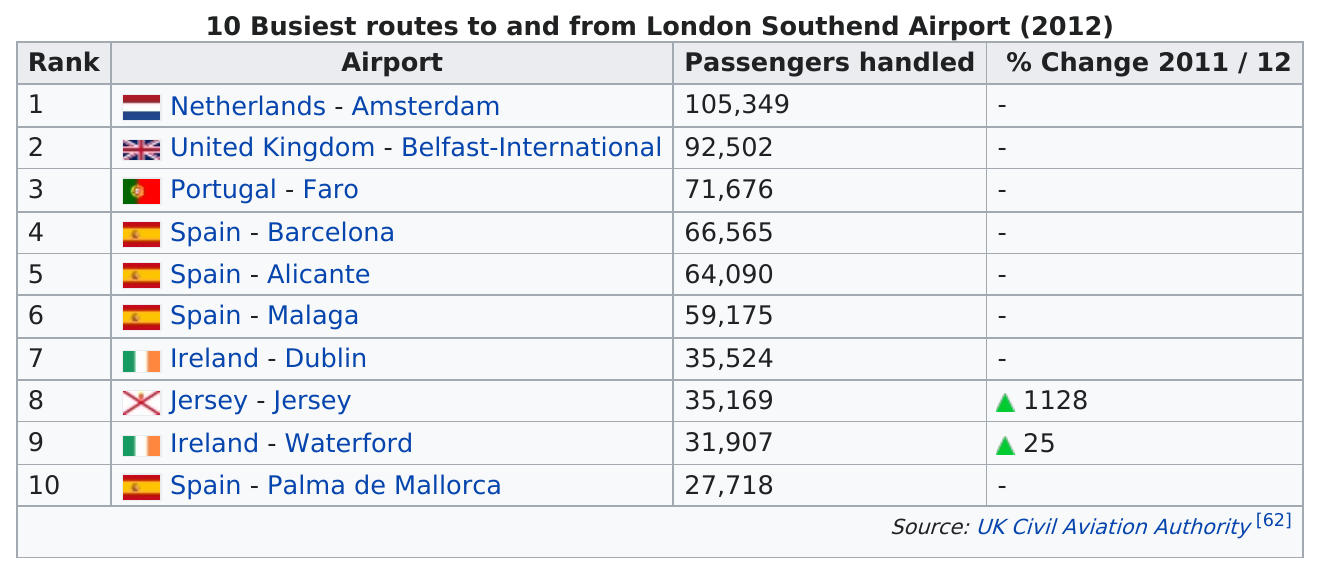Identify some key points in this picture. In 2012, four of the busiest routes to and from London Southend Airport were airports in Spain. London Southend Airport is the least busy airport in the UK, with the least amount of passengers going through it compared to other airports in the UK. Palma de Mallorca in Spain is one of the airports that passengers from London Southend Airport fly to. Spain had the most airports listed. Based on our analysis of the top 10 busiest routes departing from London Southend Airport, the average number of passengers handled is approximately 58,967.5 per day. According to the data, a total of 217,548 passengers are either travelling to or coming from Spain. 